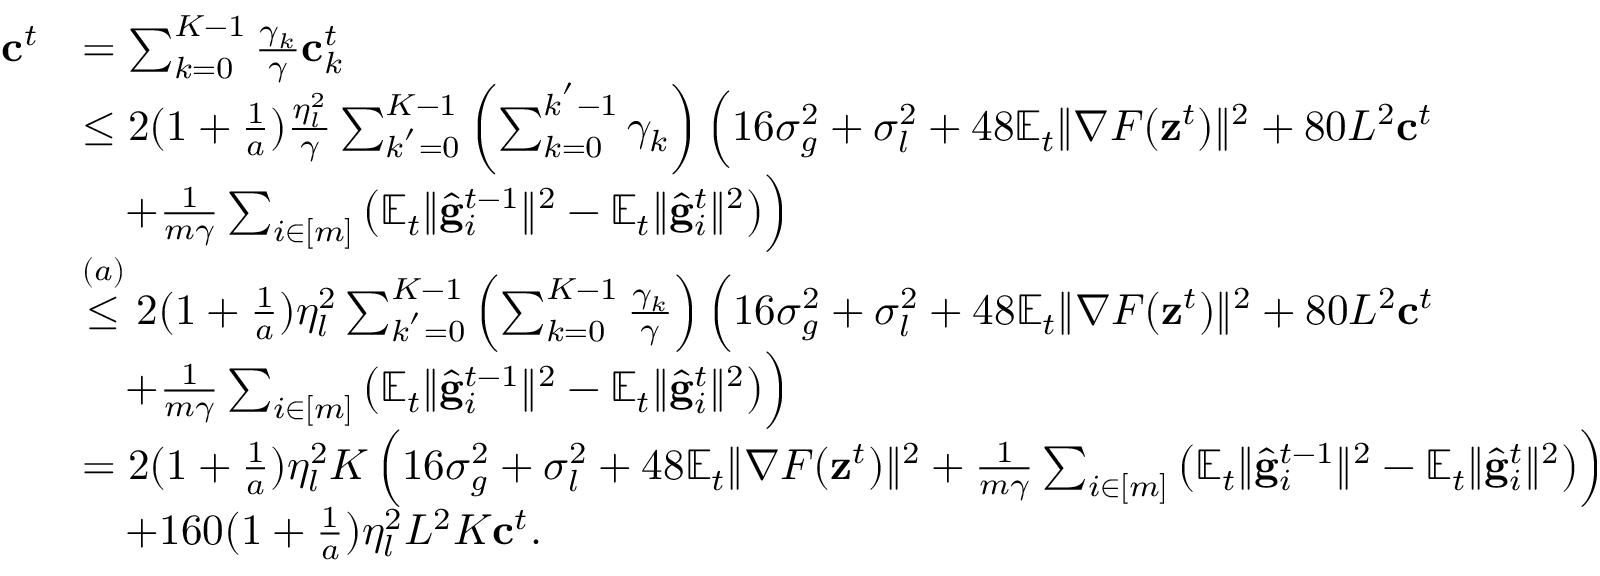<formula> <loc_0><loc_0><loc_500><loc_500>\begin{array} { r l } { c ^ { t } } & { = \sum _ { k = 0 } ^ { K - 1 } \frac { \gamma _ { k } } { \gamma } c _ { k } ^ { t } } \\ & { \leq 2 ( 1 + \frac { 1 } { a } ) \frac { \eta _ { l } ^ { 2 } } { \gamma } \sum _ { k ^ { ^ { \prime } } = 0 } ^ { K - 1 } \left ( \sum _ { k = 0 } ^ { k ^ { ^ { \prime } } - 1 } \gamma _ { k } \right ) \left ( 1 6 \sigma _ { g } ^ { 2 } + \sigma _ { l } ^ { 2 } + 4 8 \mathbb { E } _ { t } \| \nabla F ( z ^ { t } ) \| ^ { 2 } + 8 0 L ^ { 2 } c ^ { t } } \\ & { \quad + \frac { 1 } { m \gamma } \sum _ { i \in [ m ] } \left ( \mathbb { E } _ { t } \| \hat { g } _ { i } ^ { t - 1 } \| ^ { 2 } - \mathbb { E } _ { t } \| \hat { g } _ { i } ^ { t } \| ^ { 2 } \right ) \right ) } \\ & { \overset { ( a ) } { \leq } 2 ( 1 + \frac { 1 } { a } ) \eta _ { l } ^ { 2 } \sum _ { k ^ { ^ { \prime } } = 0 } ^ { K - 1 } \left ( \sum _ { k = 0 } ^ { K - 1 } \frac { \gamma _ { k } } { \gamma } \right ) \left ( 1 6 \sigma _ { g } ^ { 2 } + \sigma _ { l } ^ { 2 } + 4 8 \mathbb { E } _ { t } \| \nabla F ( z ^ { t } ) \| ^ { 2 } + 8 0 L ^ { 2 } c ^ { t } } \\ & { \quad + \frac { 1 } { m \gamma } \sum _ { i \in [ m ] } \left ( \mathbb { E } _ { t } \| \hat { g } _ { i } ^ { t - 1 } \| ^ { 2 } - \mathbb { E } _ { t } \| \hat { g } _ { i } ^ { t } \| ^ { 2 } \right ) \right ) } \\ & { = 2 ( 1 + \frac { 1 } { a } ) \eta _ { l } ^ { 2 } K \left ( 1 6 \sigma _ { g } ^ { 2 } + \sigma _ { l } ^ { 2 } + 4 8 \mathbb { E } _ { t } \| \nabla F ( z ^ { t } ) \| ^ { 2 } + \frac { 1 } { m \gamma } \sum _ { i \in [ m ] } \left ( \mathbb { E } _ { t } \| \hat { g } _ { i } ^ { t - 1 } \| ^ { 2 } - \mathbb { E } _ { t } \| \hat { g } _ { i } ^ { t } \| ^ { 2 } \right ) \right ) } \\ & { \quad + 1 6 0 ( 1 + \frac { 1 } { a } ) \eta _ { l } ^ { 2 } L ^ { 2 } K c ^ { t } . } \end{array}</formula> 